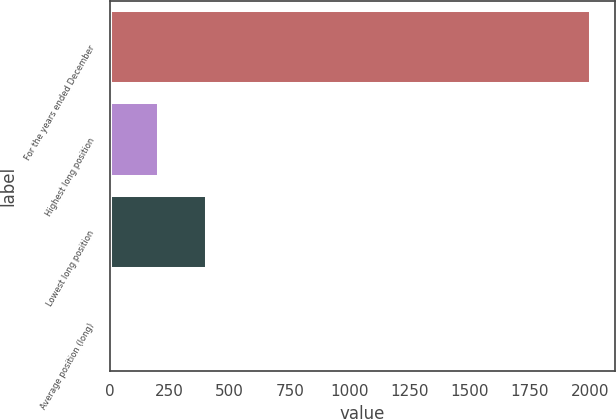Convert chart. <chart><loc_0><loc_0><loc_500><loc_500><bar_chart><fcel>For the years ended December<fcel>Highest long position<fcel>Lowest long position<fcel>Average position (long)<nl><fcel>2006<fcel>203.93<fcel>404.16<fcel>3.7<nl></chart> 